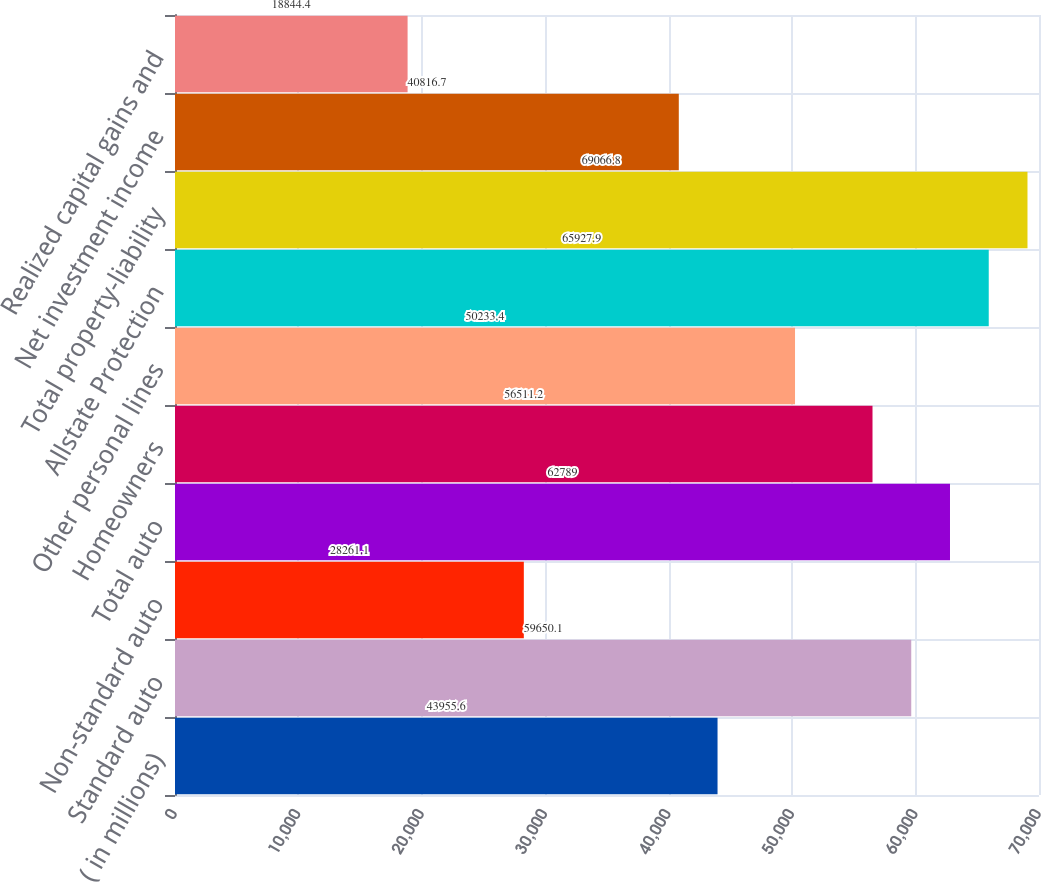Convert chart. <chart><loc_0><loc_0><loc_500><loc_500><bar_chart><fcel>( in millions)<fcel>Standard auto<fcel>Non-standard auto<fcel>Total auto<fcel>Homeowners<fcel>Other personal lines<fcel>Allstate Protection<fcel>Total property-liability<fcel>Net investment income<fcel>Realized capital gains and<nl><fcel>43955.6<fcel>59650.1<fcel>28261.1<fcel>62789<fcel>56511.2<fcel>50233.4<fcel>65927.9<fcel>69066.8<fcel>40816.7<fcel>18844.4<nl></chart> 